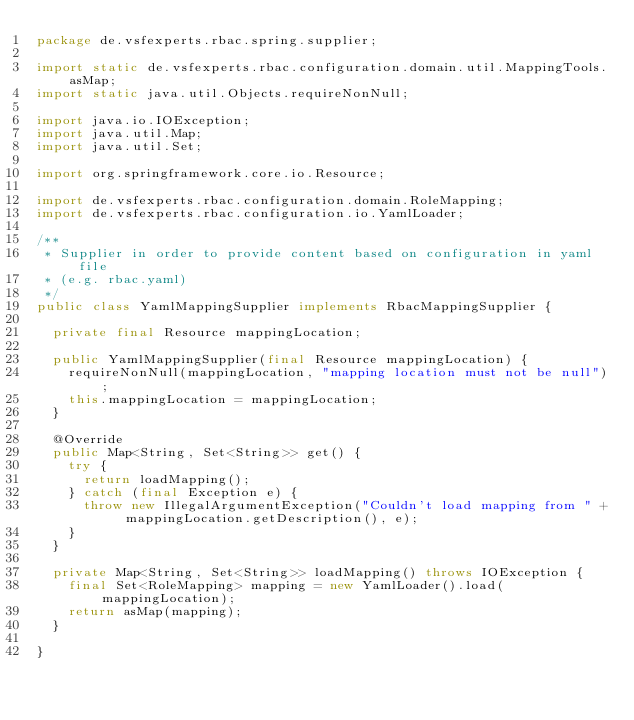Convert code to text. <code><loc_0><loc_0><loc_500><loc_500><_Java_>package de.vsfexperts.rbac.spring.supplier;

import static de.vsfexperts.rbac.configuration.domain.util.MappingTools.asMap;
import static java.util.Objects.requireNonNull;

import java.io.IOException;
import java.util.Map;
import java.util.Set;

import org.springframework.core.io.Resource;

import de.vsfexperts.rbac.configuration.domain.RoleMapping;
import de.vsfexperts.rbac.configuration.io.YamlLoader;

/**
 * Supplier in order to provide content based on configuration in yaml file
 * (e.g. rbac.yaml)
 */
public class YamlMappingSupplier implements RbacMappingSupplier {

	private final Resource mappingLocation;

	public YamlMappingSupplier(final Resource mappingLocation) {
		requireNonNull(mappingLocation, "mapping location must not be null");
		this.mappingLocation = mappingLocation;
	}

	@Override
	public Map<String, Set<String>> get() {
		try {
			return loadMapping();
		} catch (final Exception e) {
			throw new IllegalArgumentException("Couldn't load mapping from " + mappingLocation.getDescription(), e);
		}
	}

	private Map<String, Set<String>> loadMapping() throws IOException {
		final Set<RoleMapping> mapping = new YamlLoader().load(mappingLocation);
		return asMap(mapping);
	}

}
</code> 